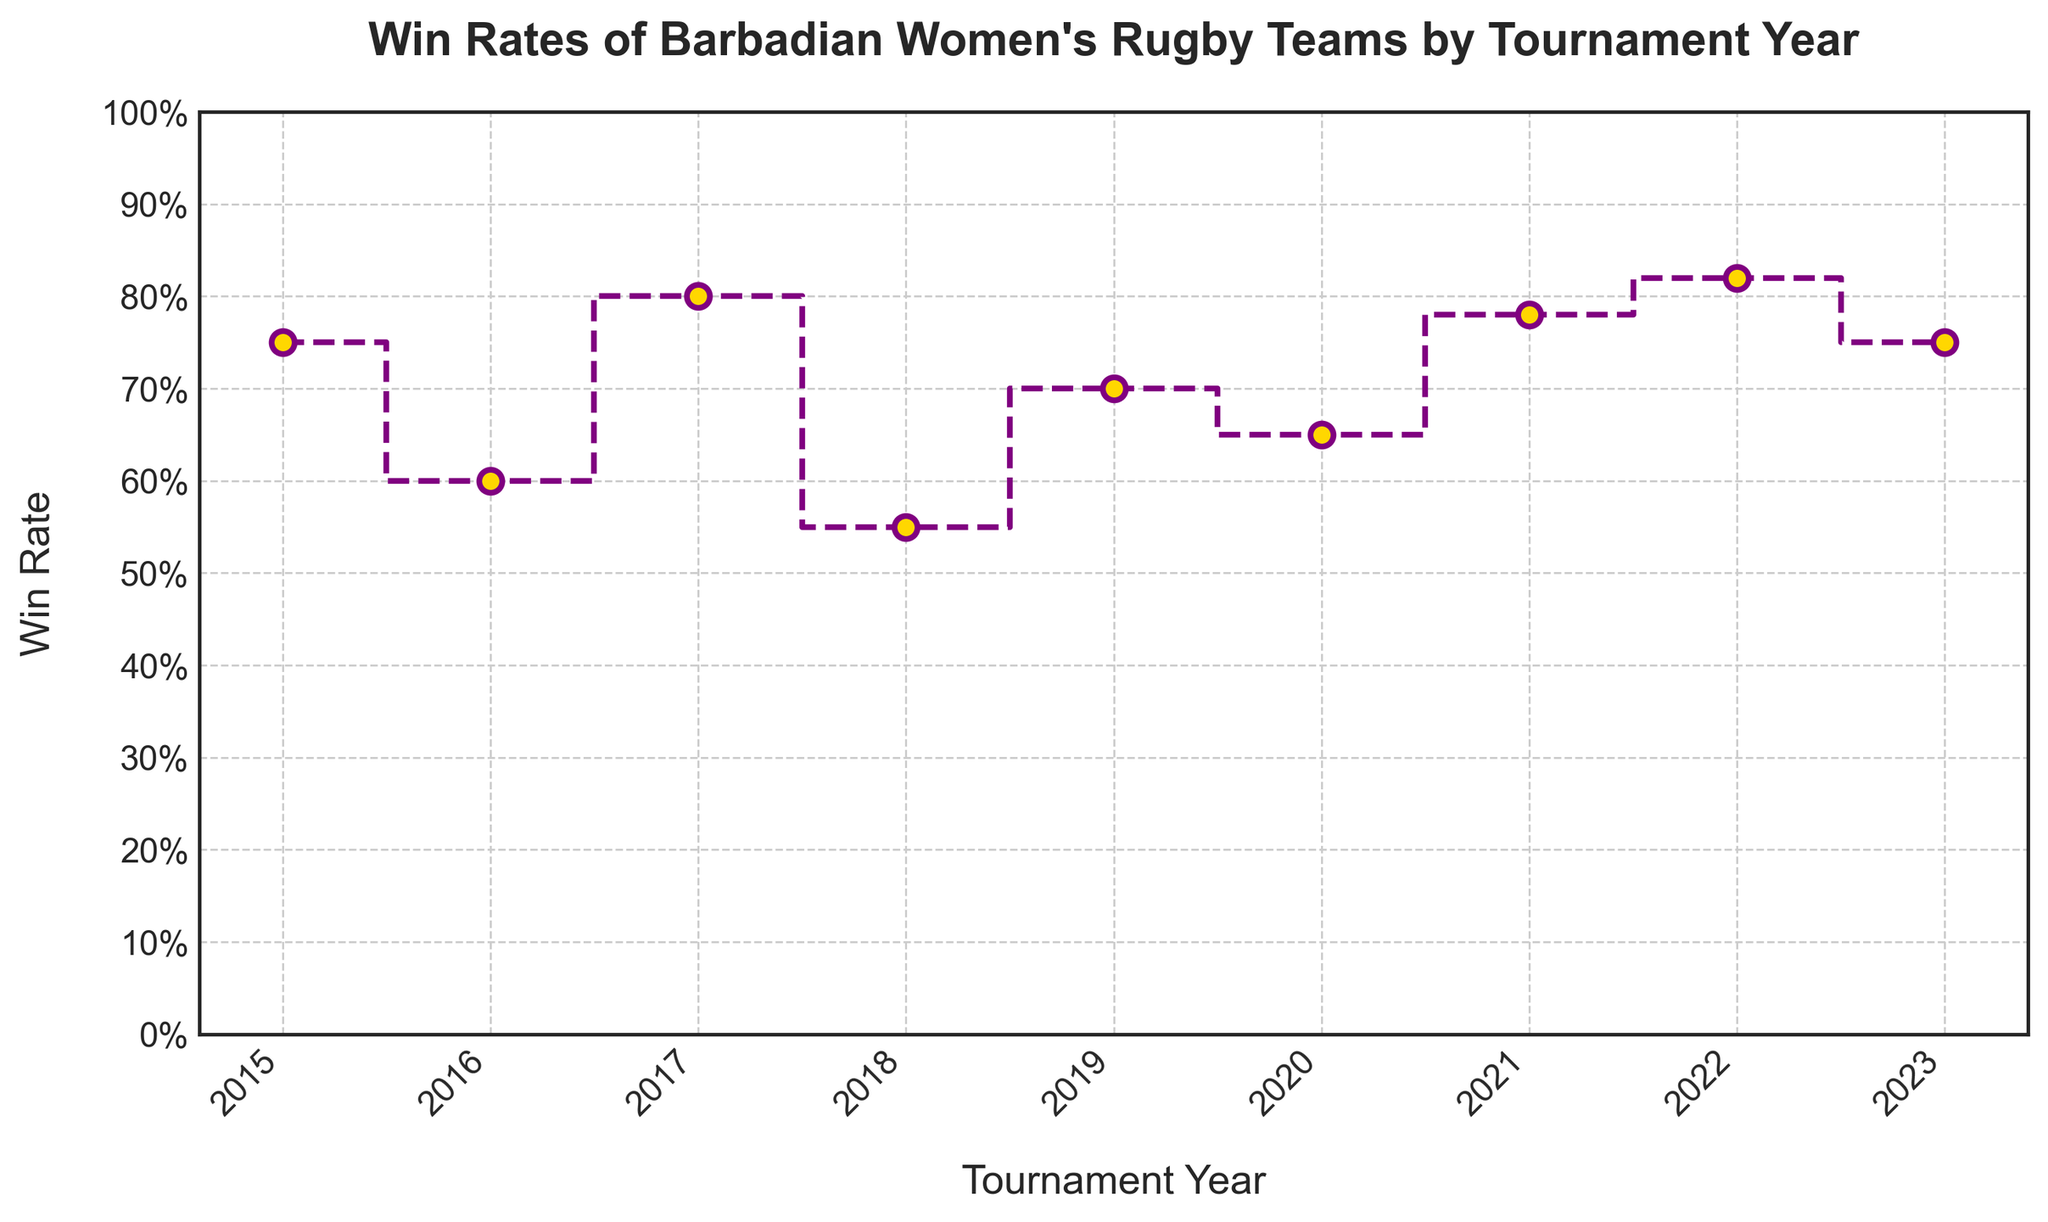What is the win rate for the year 2021? Locate the year 2021 on the x-axis and identify the corresponding y-axis value, which represents the win rate.
Answer: 0.78 Which year had the highest win rate? Look at all the win rates on the y-axis and find the highest value, then find the corresponding year on the x-axis.
Answer: 2022 What is the average win rate from 2015 to 2023? Add all the win rates from 2015 to 2023 and divide by the number of years (9). The sum is 0.75 + 0.60 + 0.80 + 0.55 + 0.70 + 0.65 + 0.78 + 0.82 + 0.75 = 6.4. Thus, the average is 6.4 / 9 = 0.7111.
Answer: 0.71 By how much did the win rate change from 2018 to 2019? Subtract the win rate of 2018 from the win rate of 2019: 0.70 - 0.55 = 0.15.
Answer: 0.15 Did the win rate increase or decrease between 2020 and 2021? Compare the win rates of 2020 and 2021: 0.65 and 0.78. Since 0.78 > 0.65, the win rate increased.
Answer: Increased Which year had the lowest win rate? Look at all the win rates on the y-axis and find the lowest value, then identify the corresponding year on the x-axis.
Answer: 2018 What’s the difference between the highest and lowest win rates? Subtract the lowest win rate (0.55 in 2018) from the highest win rate (0.82 in 2022): 0.82 - 0.55 = 0.27.
Answer: 0.27 What is the win rate trend from 2017 to 2018? Compare the win rates of 2017 (0.80) and 2018 (0.55). Since 0.55 < 0.80, the trend is a decrease.
Answer: Decrease How many years did the win rate fluctuate between 0.7 and 0.8? Count the years where the win rate is between 0.7 and 0.8: 2015 (0.75), 2017 (0.80), 2019 (0.70), 2021 (0.78), and 2023 (0.75).
Answer: 5 By what percentage did the win rate improve from 2016 to 2017? Calculate the percentage change: ((0.80 - 0.60) / 0.60) * 100 = 33.33%.
Answer: 33.33% 